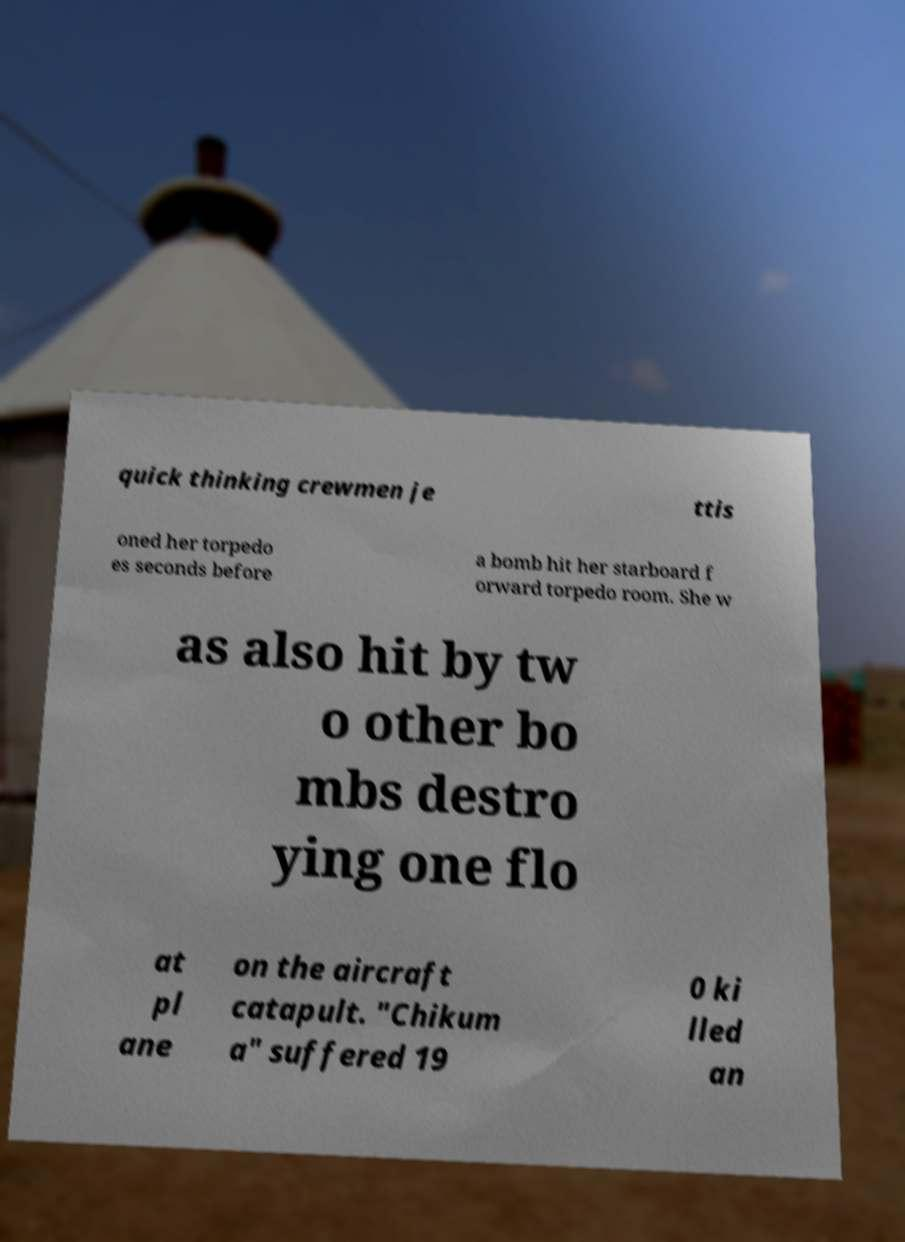Can you accurately transcribe the text from the provided image for me? quick thinking crewmen je ttis oned her torpedo es seconds before a bomb hit her starboard f orward torpedo room. She w as also hit by tw o other bo mbs destro ying one flo at pl ane on the aircraft catapult. "Chikum a" suffered 19 0 ki lled an 